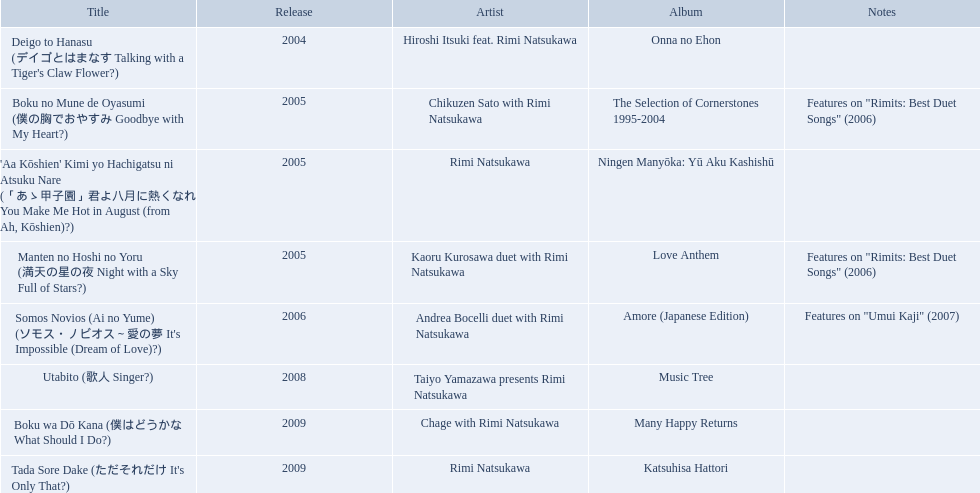What are all of the titles? Deigo to Hanasu (デイゴとはまなす Talking with a Tiger's Claw Flower?), Boku no Mune de Oyasumi (僕の胸でおやすみ Goodbye with My Heart?), 'Aa Kōshien' Kimi yo Hachigatsu ni Atsuku Nare (「あゝ甲子園」君よ八月に熱くなれ You Make Me Hot in August (from Ah, Kōshien)?), Manten no Hoshi no Yoru (満天の星の夜 Night with a Sky Full of Stars?), Somos Novios (Ai no Yume) (ソモス・ノビオス～愛の夢 It's Impossible (Dream of Love)?), Utabito (歌人 Singer?), Boku wa Dō Kana (僕はどうかな What Should I Do?), Tada Sore Dake (ただそれだけ It's Only That?). What are their notes? , Features on "Rimits: Best Duet Songs" (2006), , Features on "Rimits: Best Duet Songs" (2006), Features on "Umui Kaji" (2007), , , . Which title shares its notes with manten no hoshi no yoru (man tian noxing noye night with a sky full of stars?)? Boku no Mune de Oyasumi (僕の胸でおやすみ Goodbye with My Heart?). 